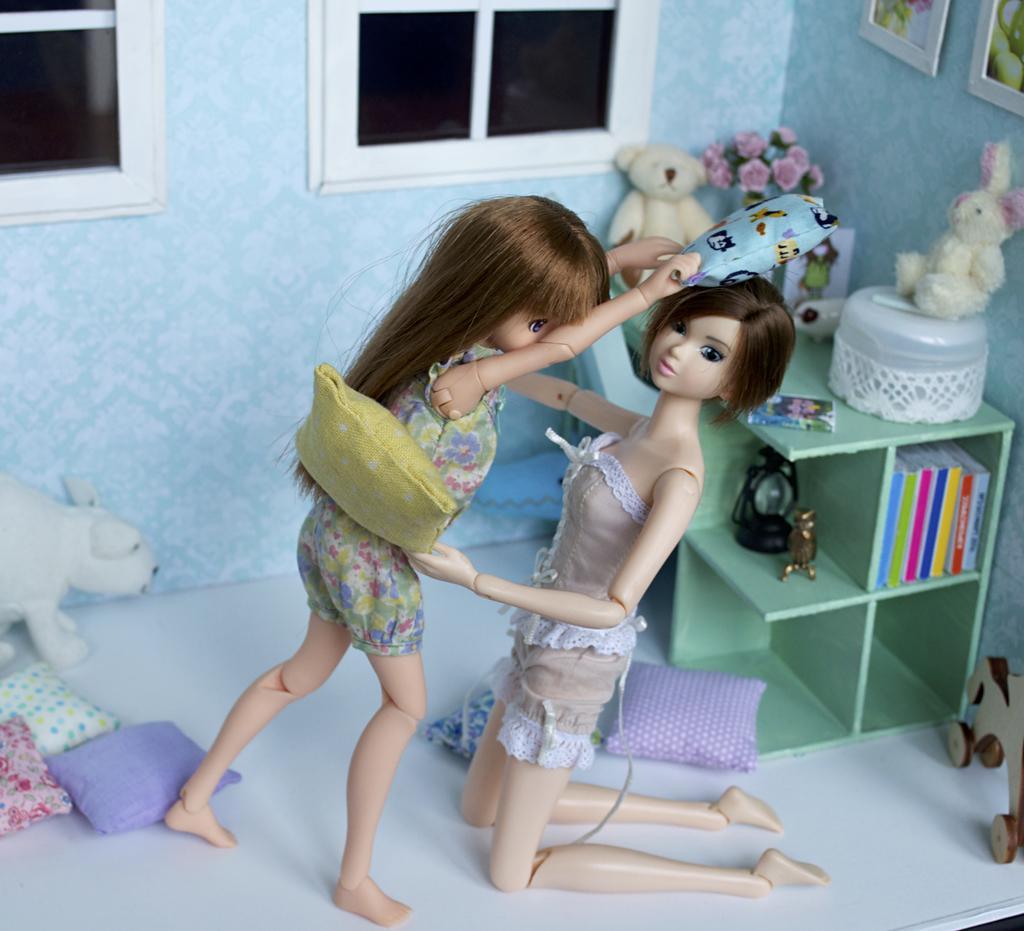In one or two sentences, can you explain what this image depicts? In this image I can see two barbie dolls, few pillows, toys, windows, few frames are attached to the wall. I can see few objects on the table and I can see the book rack and few objects in it. 